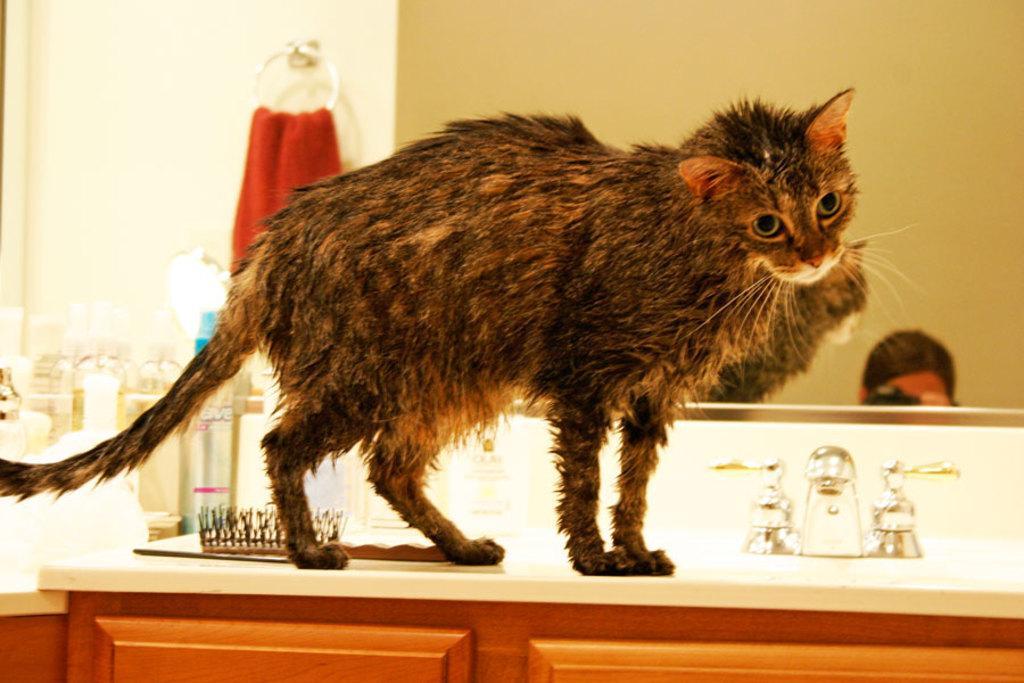Can you describe this image briefly? In this picture I can see a brown color cat near to the taps and near to it I can see a comb and other few things. In the background I can see a red color cloth and a mirror and on the mirror I can see the reflection of a person's head. 